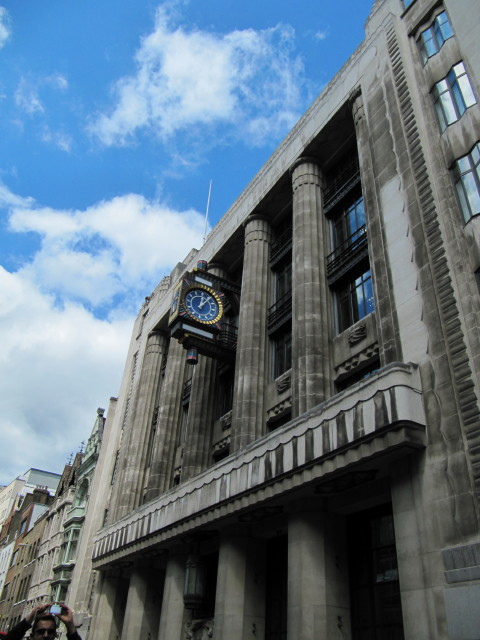<image>What is the blue sign with a 2 on it for? It is unknown what the blue sign with a 2 on it is for. It could possibly indicate a clock or time. What is the blue sign with a 2 on it for? I don't know what the blue sign with a 2 on it is for. 